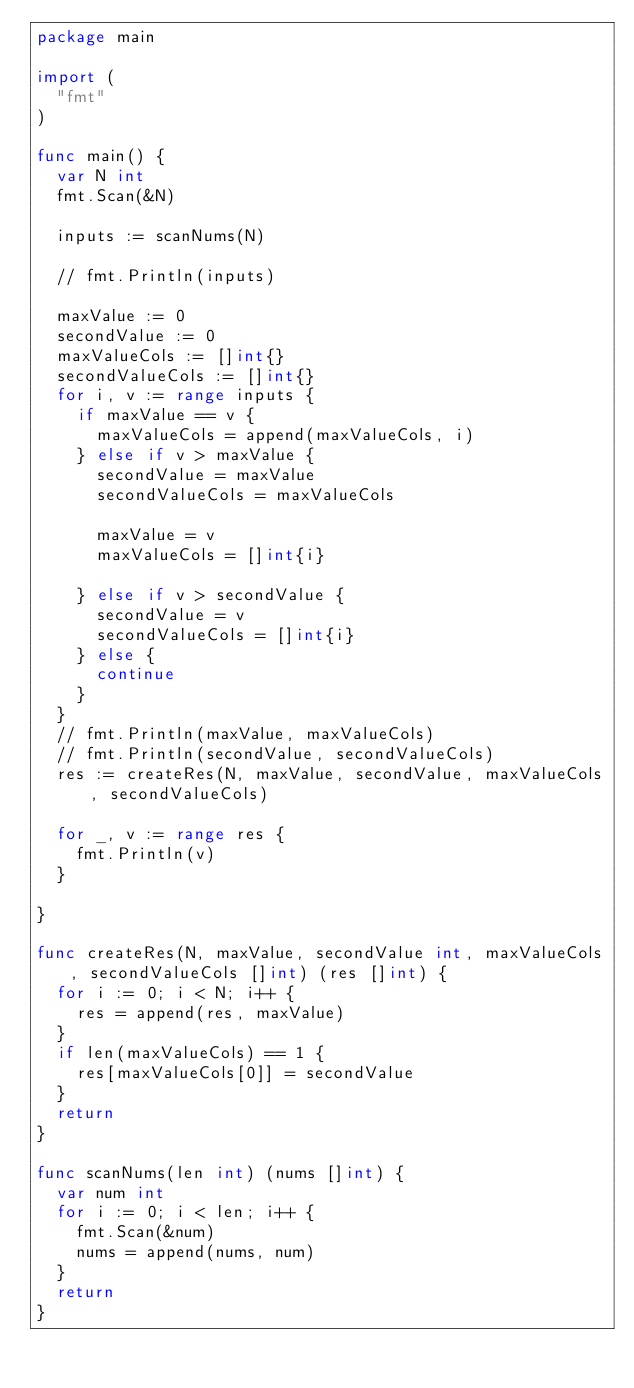Convert code to text. <code><loc_0><loc_0><loc_500><loc_500><_Go_>package main

import (
	"fmt"
)

func main() {
	var N int
	fmt.Scan(&N)

	inputs := scanNums(N)

	// fmt.Println(inputs)

	maxValue := 0
	secondValue := 0
	maxValueCols := []int{}
	secondValueCols := []int{}
	for i, v := range inputs {
		if maxValue == v {
			maxValueCols = append(maxValueCols, i)
		} else if v > maxValue {
			secondValue = maxValue
			secondValueCols = maxValueCols

			maxValue = v
			maxValueCols = []int{i}

		} else if v > secondValue {
			secondValue = v
			secondValueCols = []int{i}
		} else {
			continue
		}
	}
	// fmt.Println(maxValue, maxValueCols)
	// fmt.Println(secondValue, secondValueCols)
	res := createRes(N, maxValue, secondValue, maxValueCols, secondValueCols)

	for _, v := range res {
		fmt.Println(v)
	}

}

func createRes(N, maxValue, secondValue int, maxValueCols, secondValueCols []int) (res []int) {
	for i := 0; i < N; i++ {
		res = append(res, maxValue)
	}
	if len(maxValueCols) == 1 {
		res[maxValueCols[0]] = secondValue
	}
	return
}

func scanNums(len int) (nums []int) {
	var num int
	for i := 0; i < len; i++ {
		fmt.Scan(&num)
		nums = append(nums, num)
	}
	return
}
</code> 